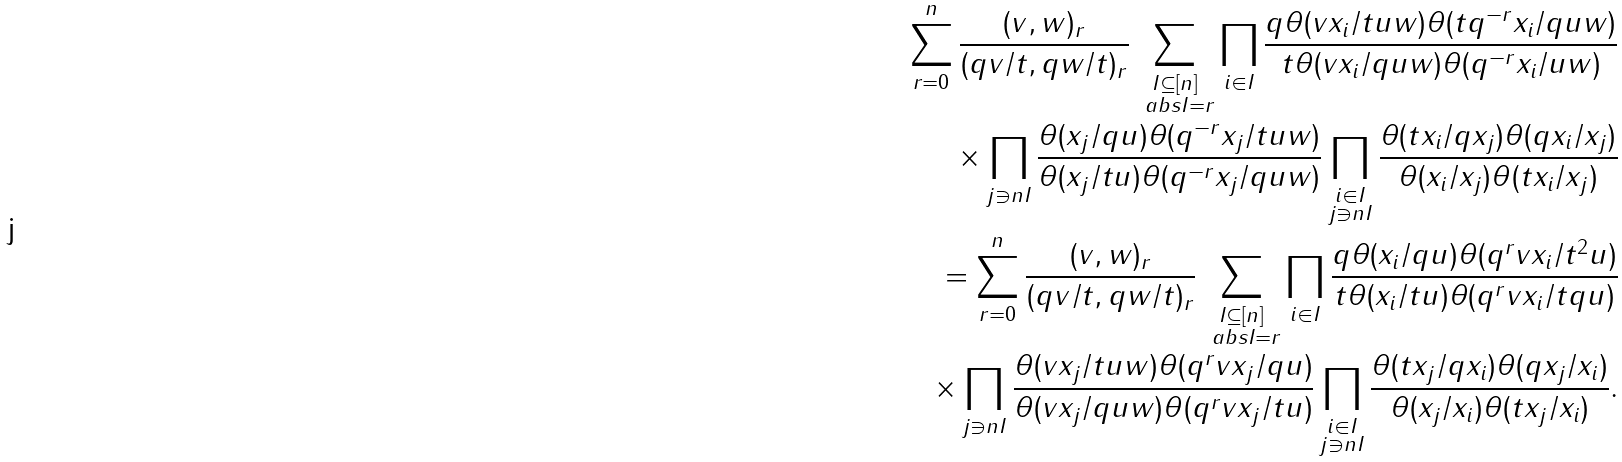Convert formula to latex. <formula><loc_0><loc_0><loc_500><loc_500>\sum _ { r = 0 } ^ { n } \frac { ( v , w ) _ { r } } { ( q v / t , q w / t ) _ { r } } \sum _ { \substack { I \subseteq [ n ] \\ \ a b s { I } = r } } \prod _ { \substack { i \in I } } \frac { q \theta ( v x _ { i } / t u w ) \theta ( t q ^ { - r } x _ { i } / q u w ) } { t \theta ( v x _ { i } / q u w ) \theta ( q ^ { - r } x _ { i } / u w ) } \\ \quad \times \prod _ { j \ni n I } \frac { \theta ( x _ { j } / q u ) \theta ( q ^ { - r } x _ { j } / t u w ) } { \theta ( x _ { j } / t u ) \theta ( q ^ { - r } x _ { j } / q u w ) } \prod _ { \substack { i \in I \\ j \ni n I } } \frac { \theta ( t x _ { i } / q x _ { j } ) \theta ( q x _ { i } / x _ { j } ) } { \theta ( x _ { i } / x _ { j } ) \theta ( t x _ { i } / x _ { j } ) } \\ = \sum _ { r = 0 } ^ { n } \frac { ( v , w ) _ { r } } { ( q v / t , q w / t ) _ { r } } \sum _ { \substack { I \subseteq [ n ] \\ \ a b s { I } = r } } \prod _ { \substack { i \in I } } \frac { q \theta ( x _ { i } / q u ) \theta ( q ^ { r } v x _ { i } / t ^ { 2 } u ) } { t \theta ( x _ { i } / t u ) \theta ( q ^ { r } v x _ { i } / t q u ) } \\ \quad \times \prod _ { \substack { j \ni n I } } \frac { \theta ( v x _ { j } / t u w ) \theta ( q ^ { r } v x _ { j } / q u ) } { \theta ( v x _ { j } / q u w ) \theta ( q ^ { r } v x _ { j } / t u ) } \prod _ { \substack { i \in I \\ j \ni n I } } \frac { \theta ( t x _ { j } / q x _ { i } ) \theta ( q x _ { j } / x _ { i } ) } { \theta ( x _ { j } / x _ { i } ) \theta ( t x _ { j } / x _ { i } ) } .</formula> 